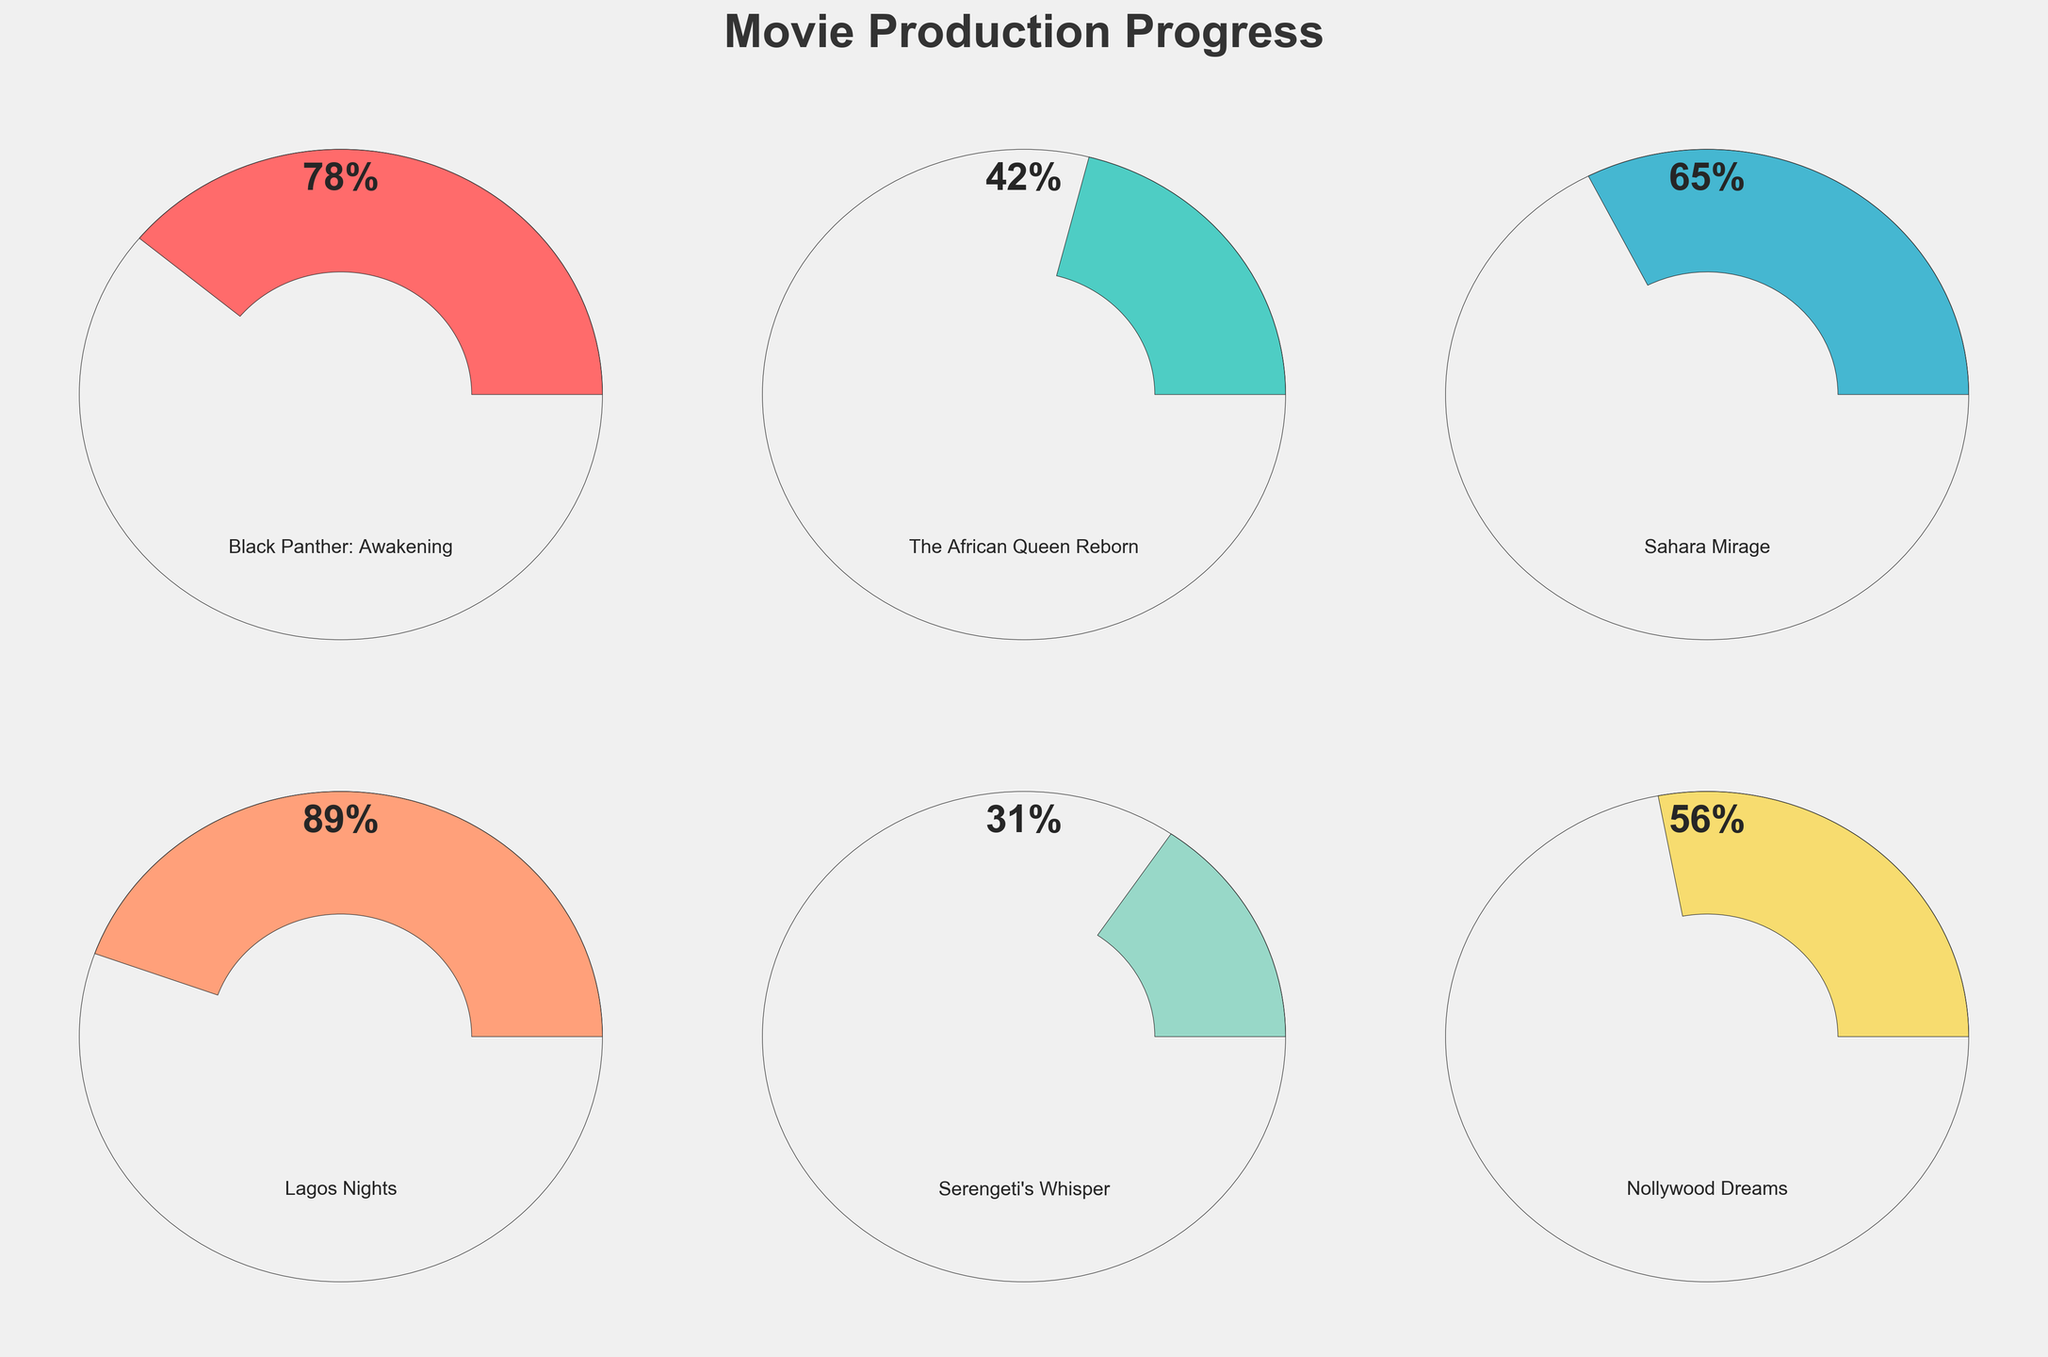Which movie project has the highest completion percentage? By looking at the gauge charts, we identify the gauge with the largest progress, which is "Lagos Nights" at 89%.
Answer: Lagos Nights Which movie project has the lowest completion percentage? By examining all the gauges, the one with the smallest progress is "Serengeti's Whisper," which is at 31%.
Answer: Serengeti's Whisper How many projects are in progress? The chart displays gauges for six movie projects.
Answer: Six What is the average completion percentage of all the projects? Calculate the average by summing all completion percentages (78 + 42 + 65 + 89 + 31 + 56 = 361) and dividing by the number of projects (6). Thus, the average is 361/6 ≈ 60.2%.
Answer: 60.2% Which two movie projects have completion percentages greater than 75%? Checking each gauge, "Black Panther: Awakening" at 78% and "Lagos Nights" at 89% both exceed 75%.
Answer: Black Panther: Awakening and Lagos Nights Which project is just above halfway completed (closest to 50%)? The closest completion percentage to 50% is "Nollywood Dreams" with 56%.
Answer: Nollywood Dreams What is the difference in completion percentage between "Sahara Mirage" and "The African Queen Reborn"? Subtract the smaller completion percentage from the larger one (65% - 42% = 23%).
Answer: 23% If you combine the completion percentages of "Black Panther: Awakening" and "Nollywood Dreams," what is their total percentage? Add the two completion percentages (78% + 56% = 134%).
Answer: 134% Considering only the projects below 50% completion, which one is closest to that halfway mark? "Nollywood Dreams" with 56% is above the threshold, so "The African Queen Reborn" at 42% is the closest under 50%.
Answer: The African Queen Reborn 